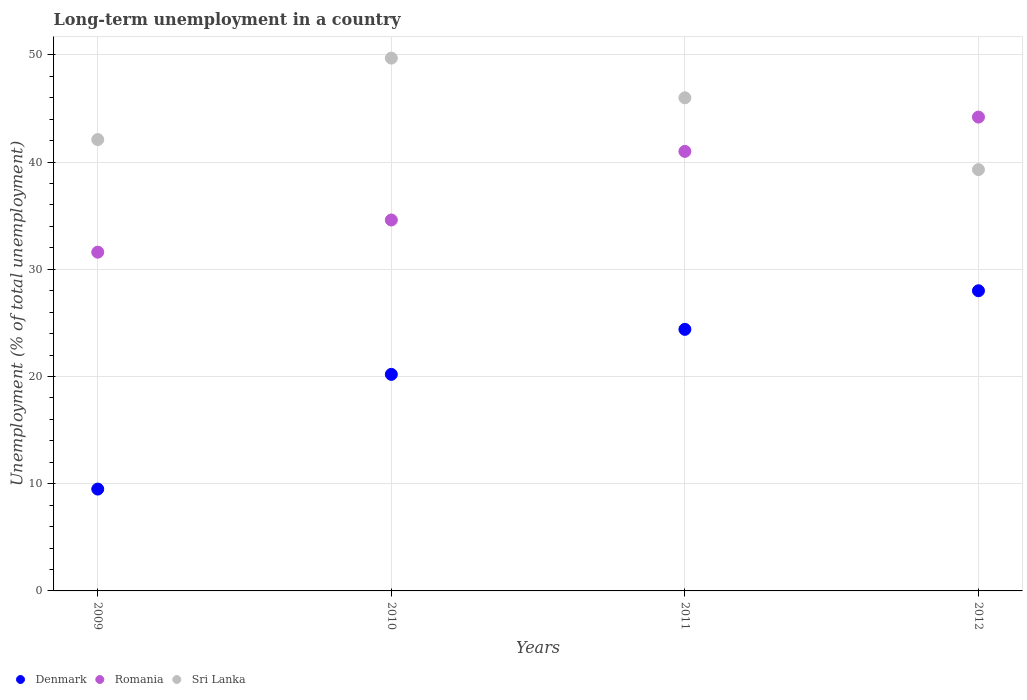How many different coloured dotlines are there?
Offer a terse response. 3. What is the percentage of long-term unemployed population in Sri Lanka in 2012?
Your answer should be very brief. 39.3. Across all years, what is the maximum percentage of long-term unemployed population in Denmark?
Your answer should be compact. 28. Across all years, what is the minimum percentage of long-term unemployed population in Romania?
Your response must be concise. 31.6. In which year was the percentage of long-term unemployed population in Sri Lanka maximum?
Make the answer very short. 2010. In which year was the percentage of long-term unemployed population in Denmark minimum?
Ensure brevity in your answer.  2009. What is the total percentage of long-term unemployed population in Romania in the graph?
Provide a succinct answer. 151.4. What is the difference between the percentage of long-term unemployed population in Denmark in 2011 and that in 2012?
Offer a terse response. -3.6. What is the difference between the percentage of long-term unemployed population in Romania in 2012 and the percentage of long-term unemployed population in Sri Lanka in 2010?
Your answer should be compact. -5.5. What is the average percentage of long-term unemployed population in Sri Lanka per year?
Your response must be concise. 44.27. In the year 2011, what is the difference between the percentage of long-term unemployed population in Romania and percentage of long-term unemployed population in Sri Lanka?
Provide a short and direct response. -5. In how many years, is the percentage of long-term unemployed population in Denmark greater than 40 %?
Your answer should be very brief. 0. What is the ratio of the percentage of long-term unemployed population in Romania in 2010 to that in 2012?
Ensure brevity in your answer.  0.78. Is the difference between the percentage of long-term unemployed population in Romania in 2009 and 2010 greater than the difference between the percentage of long-term unemployed population in Sri Lanka in 2009 and 2010?
Offer a terse response. Yes. What is the difference between the highest and the second highest percentage of long-term unemployed population in Sri Lanka?
Offer a very short reply. 3.7. What is the difference between the highest and the lowest percentage of long-term unemployed population in Romania?
Offer a very short reply. 12.6. In how many years, is the percentage of long-term unemployed population in Romania greater than the average percentage of long-term unemployed population in Romania taken over all years?
Your answer should be compact. 2. Is the sum of the percentage of long-term unemployed population in Denmark in 2009 and 2012 greater than the maximum percentage of long-term unemployed population in Romania across all years?
Keep it short and to the point. No. Is it the case that in every year, the sum of the percentage of long-term unemployed population in Denmark and percentage of long-term unemployed population in Sri Lanka  is greater than the percentage of long-term unemployed population in Romania?
Make the answer very short. Yes. Is the percentage of long-term unemployed population in Romania strictly less than the percentage of long-term unemployed population in Sri Lanka over the years?
Provide a succinct answer. No. How many dotlines are there?
Ensure brevity in your answer.  3. What is the difference between two consecutive major ticks on the Y-axis?
Keep it short and to the point. 10. How many legend labels are there?
Your response must be concise. 3. How are the legend labels stacked?
Offer a terse response. Horizontal. What is the title of the graph?
Offer a very short reply. Long-term unemployment in a country. Does "Georgia" appear as one of the legend labels in the graph?
Your answer should be compact. No. What is the label or title of the Y-axis?
Give a very brief answer. Unemployment (% of total unemployment). What is the Unemployment (% of total unemployment) of Denmark in 2009?
Make the answer very short. 9.5. What is the Unemployment (% of total unemployment) in Romania in 2009?
Offer a terse response. 31.6. What is the Unemployment (% of total unemployment) of Sri Lanka in 2009?
Your response must be concise. 42.1. What is the Unemployment (% of total unemployment) of Denmark in 2010?
Keep it short and to the point. 20.2. What is the Unemployment (% of total unemployment) in Romania in 2010?
Your answer should be compact. 34.6. What is the Unemployment (% of total unemployment) of Sri Lanka in 2010?
Give a very brief answer. 49.7. What is the Unemployment (% of total unemployment) of Denmark in 2011?
Offer a terse response. 24.4. What is the Unemployment (% of total unemployment) in Romania in 2012?
Give a very brief answer. 44.2. What is the Unemployment (% of total unemployment) of Sri Lanka in 2012?
Make the answer very short. 39.3. Across all years, what is the maximum Unemployment (% of total unemployment) of Denmark?
Your answer should be very brief. 28. Across all years, what is the maximum Unemployment (% of total unemployment) of Romania?
Give a very brief answer. 44.2. Across all years, what is the maximum Unemployment (% of total unemployment) in Sri Lanka?
Offer a terse response. 49.7. Across all years, what is the minimum Unemployment (% of total unemployment) of Romania?
Offer a terse response. 31.6. Across all years, what is the minimum Unemployment (% of total unemployment) of Sri Lanka?
Your response must be concise. 39.3. What is the total Unemployment (% of total unemployment) in Denmark in the graph?
Provide a succinct answer. 82.1. What is the total Unemployment (% of total unemployment) in Romania in the graph?
Make the answer very short. 151.4. What is the total Unemployment (% of total unemployment) of Sri Lanka in the graph?
Keep it short and to the point. 177.1. What is the difference between the Unemployment (% of total unemployment) in Denmark in 2009 and that in 2010?
Ensure brevity in your answer.  -10.7. What is the difference between the Unemployment (% of total unemployment) of Romania in 2009 and that in 2010?
Give a very brief answer. -3. What is the difference between the Unemployment (% of total unemployment) of Sri Lanka in 2009 and that in 2010?
Your response must be concise. -7.6. What is the difference between the Unemployment (% of total unemployment) in Denmark in 2009 and that in 2011?
Offer a terse response. -14.9. What is the difference between the Unemployment (% of total unemployment) in Denmark in 2009 and that in 2012?
Your answer should be compact. -18.5. What is the difference between the Unemployment (% of total unemployment) of Sri Lanka in 2009 and that in 2012?
Give a very brief answer. 2.8. What is the difference between the Unemployment (% of total unemployment) in Romania in 2010 and that in 2011?
Provide a succinct answer. -6.4. What is the difference between the Unemployment (% of total unemployment) of Sri Lanka in 2010 and that in 2011?
Offer a terse response. 3.7. What is the difference between the Unemployment (% of total unemployment) in Denmark in 2011 and that in 2012?
Your answer should be compact. -3.6. What is the difference between the Unemployment (% of total unemployment) in Romania in 2011 and that in 2012?
Ensure brevity in your answer.  -3.2. What is the difference between the Unemployment (% of total unemployment) of Sri Lanka in 2011 and that in 2012?
Offer a very short reply. 6.7. What is the difference between the Unemployment (% of total unemployment) of Denmark in 2009 and the Unemployment (% of total unemployment) of Romania in 2010?
Provide a succinct answer. -25.1. What is the difference between the Unemployment (% of total unemployment) in Denmark in 2009 and the Unemployment (% of total unemployment) in Sri Lanka in 2010?
Keep it short and to the point. -40.2. What is the difference between the Unemployment (% of total unemployment) of Romania in 2009 and the Unemployment (% of total unemployment) of Sri Lanka in 2010?
Provide a short and direct response. -18.1. What is the difference between the Unemployment (% of total unemployment) in Denmark in 2009 and the Unemployment (% of total unemployment) in Romania in 2011?
Your answer should be compact. -31.5. What is the difference between the Unemployment (% of total unemployment) of Denmark in 2009 and the Unemployment (% of total unemployment) of Sri Lanka in 2011?
Make the answer very short. -36.5. What is the difference between the Unemployment (% of total unemployment) in Romania in 2009 and the Unemployment (% of total unemployment) in Sri Lanka in 2011?
Provide a short and direct response. -14.4. What is the difference between the Unemployment (% of total unemployment) in Denmark in 2009 and the Unemployment (% of total unemployment) in Romania in 2012?
Keep it short and to the point. -34.7. What is the difference between the Unemployment (% of total unemployment) of Denmark in 2009 and the Unemployment (% of total unemployment) of Sri Lanka in 2012?
Provide a succinct answer. -29.8. What is the difference between the Unemployment (% of total unemployment) in Romania in 2009 and the Unemployment (% of total unemployment) in Sri Lanka in 2012?
Offer a terse response. -7.7. What is the difference between the Unemployment (% of total unemployment) in Denmark in 2010 and the Unemployment (% of total unemployment) in Romania in 2011?
Provide a succinct answer. -20.8. What is the difference between the Unemployment (% of total unemployment) of Denmark in 2010 and the Unemployment (% of total unemployment) of Sri Lanka in 2011?
Provide a short and direct response. -25.8. What is the difference between the Unemployment (% of total unemployment) in Denmark in 2010 and the Unemployment (% of total unemployment) in Sri Lanka in 2012?
Keep it short and to the point. -19.1. What is the difference between the Unemployment (% of total unemployment) in Romania in 2010 and the Unemployment (% of total unemployment) in Sri Lanka in 2012?
Keep it short and to the point. -4.7. What is the difference between the Unemployment (% of total unemployment) in Denmark in 2011 and the Unemployment (% of total unemployment) in Romania in 2012?
Provide a short and direct response. -19.8. What is the difference between the Unemployment (% of total unemployment) of Denmark in 2011 and the Unemployment (% of total unemployment) of Sri Lanka in 2012?
Your response must be concise. -14.9. What is the difference between the Unemployment (% of total unemployment) of Romania in 2011 and the Unemployment (% of total unemployment) of Sri Lanka in 2012?
Offer a terse response. 1.7. What is the average Unemployment (% of total unemployment) of Denmark per year?
Offer a terse response. 20.52. What is the average Unemployment (% of total unemployment) in Romania per year?
Give a very brief answer. 37.85. What is the average Unemployment (% of total unemployment) of Sri Lanka per year?
Offer a very short reply. 44.27. In the year 2009, what is the difference between the Unemployment (% of total unemployment) of Denmark and Unemployment (% of total unemployment) of Romania?
Offer a terse response. -22.1. In the year 2009, what is the difference between the Unemployment (% of total unemployment) in Denmark and Unemployment (% of total unemployment) in Sri Lanka?
Provide a succinct answer. -32.6. In the year 2009, what is the difference between the Unemployment (% of total unemployment) in Romania and Unemployment (% of total unemployment) in Sri Lanka?
Keep it short and to the point. -10.5. In the year 2010, what is the difference between the Unemployment (% of total unemployment) of Denmark and Unemployment (% of total unemployment) of Romania?
Make the answer very short. -14.4. In the year 2010, what is the difference between the Unemployment (% of total unemployment) of Denmark and Unemployment (% of total unemployment) of Sri Lanka?
Keep it short and to the point. -29.5. In the year 2010, what is the difference between the Unemployment (% of total unemployment) in Romania and Unemployment (% of total unemployment) in Sri Lanka?
Make the answer very short. -15.1. In the year 2011, what is the difference between the Unemployment (% of total unemployment) in Denmark and Unemployment (% of total unemployment) in Romania?
Ensure brevity in your answer.  -16.6. In the year 2011, what is the difference between the Unemployment (% of total unemployment) in Denmark and Unemployment (% of total unemployment) in Sri Lanka?
Keep it short and to the point. -21.6. In the year 2011, what is the difference between the Unemployment (% of total unemployment) in Romania and Unemployment (% of total unemployment) in Sri Lanka?
Offer a very short reply. -5. In the year 2012, what is the difference between the Unemployment (% of total unemployment) in Denmark and Unemployment (% of total unemployment) in Romania?
Ensure brevity in your answer.  -16.2. What is the ratio of the Unemployment (% of total unemployment) of Denmark in 2009 to that in 2010?
Offer a very short reply. 0.47. What is the ratio of the Unemployment (% of total unemployment) of Romania in 2009 to that in 2010?
Provide a succinct answer. 0.91. What is the ratio of the Unemployment (% of total unemployment) of Sri Lanka in 2009 to that in 2010?
Offer a very short reply. 0.85. What is the ratio of the Unemployment (% of total unemployment) in Denmark in 2009 to that in 2011?
Give a very brief answer. 0.39. What is the ratio of the Unemployment (% of total unemployment) in Romania in 2009 to that in 2011?
Your answer should be compact. 0.77. What is the ratio of the Unemployment (% of total unemployment) of Sri Lanka in 2009 to that in 2011?
Your response must be concise. 0.92. What is the ratio of the Unemployment (% of total unemployment) of Denmark in 2009 to that in 2012?
Offer a terse response. 0.34. What is the ratio of the Unemployment (% of total unemployment) of Romania in 2009 to that in 2012?
Your answer should be compact. 0.71. What is the ratio of the Unemployment (% of total unemployment) in Sri Lanka in 2009 to that in 2012?
Provide a succinct answer. 1.07. What is the ratio of the Unemployment (% of total unemployment) of Denmark in 2010 to that in 2011?
Give a very brief answer. 0.83. What is the ratio of the Unemployment (% of total unemployment) in Romania in 2010 to that in 2011?
Your answer should be very brief. 0.84. What is the ratio of the Unemployment (% of total unemployment) of Sri Lanka in 2010 to that in 2011?
Your answer should be very brief. 1.08. What is the ratio of the Unemployment (% of total unemployment) of Denmark in 2010 to that in 2012?
Give a very brief answer. 0.72. What is the ratio of the Unemployment (% of total unemployment) in Romania in 2010 to that in 2012?
Your answer should be compact. 0.78. What is the ratio of the Unemployment (% of total unemployment) in Sri Lanka in 2010 to that in 2012?
Offer a very short reply. 1.26. What is the ratio of the Unemployment (% of total unemployment) in Denmark in 2011 to that in 2012?
Provide a succinct answer. 0.87. What is the ratio of the Unemployment (% of total unemployment) in Romania in 2011 to that in 2012?
Keep it short and to the point. 0.93. What is the ratio of the Unemployment (% of total unemployment) in Sri Lanka in 2011 to that in 2012?
Your answer should be very brief. 1.17. What is the difference between the highest and the second highest Unemployment (% of total unemployment) in Romania?
Your answer should be very brief. 3.2. What is the difference between the highest and the lowest Unemployment (% of total unemployment) in Romania?
Your answer should be very brief. 12.6. 